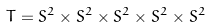<formula> <loc_0><loc_0><loc_500><loc_500>T = S ^ { 2 } \times S ^ { 2 } \times S ^ { 2 } \times S ^ { 2 } \times S ^ { 2 }</formula> 